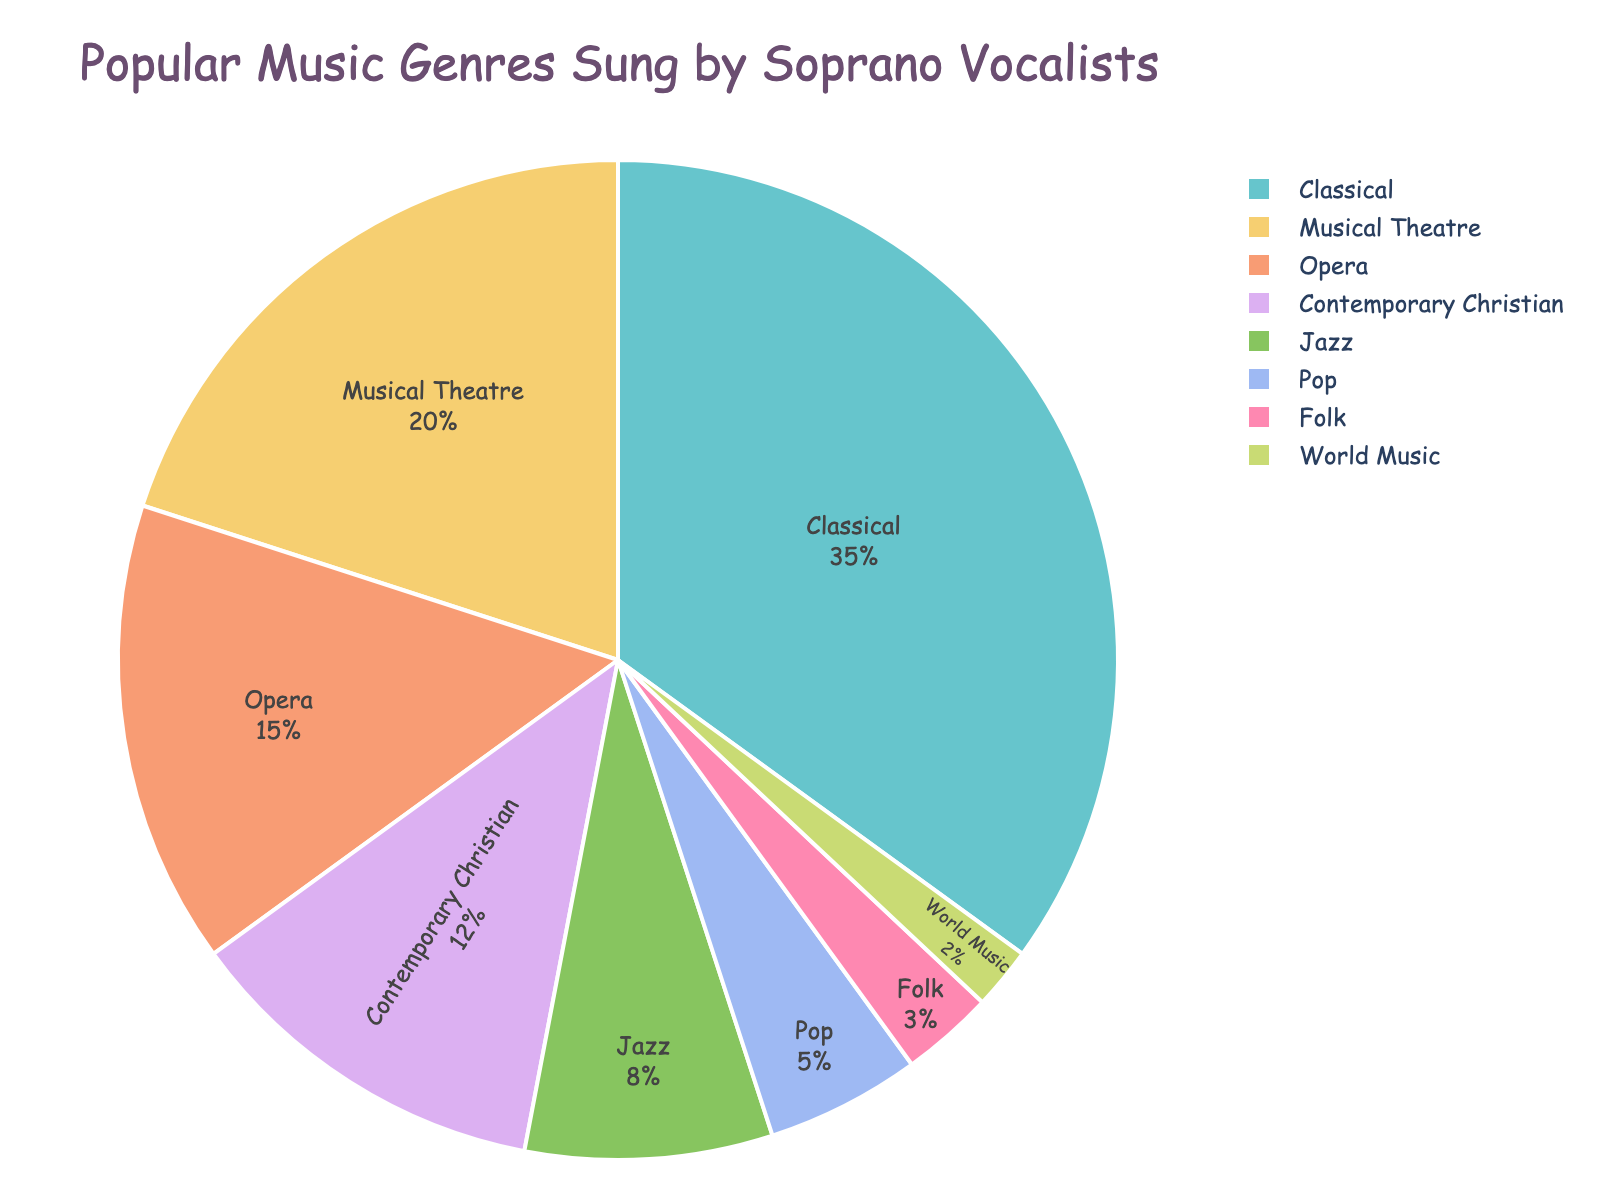What is the most popular music genre sung by soprano vocalists? The pie chart shows the breakdown of popular music genres sung by soprano vocalists by their percentages. The segment with the highest percentage represents the most popular genre. By looking at the chart, we see that Classical has the highest percentage at 35%.
Answer: Classical Which genre has a larger percentage, Opera or Contemporary Christian? To determine which genre has a larger percentage, we compare the slices in the pie chart labeled "Opera" and "Contemporary Christian". Opera has a percentage of 15%, while Contemporary Christian has 12%.
Answer: Opera What is the combined percentage of Musical Theatre and Jazz? We need to sum the percentages of Musical Theatre and Jazz as shown in the pie chart. Musical Theatre is 20% and Jazz is 8%, so the combined percentage is 20% + 8% = 28%.
Answer: 28% How much larger is the Classical genre compared to Pop? To find out how much larger the Classical genre is compared to the Pop genre, we subtract the percentage of Pop from the percentage of Classical. Classical has 35%, and Pop has 5%, so the difference is 35% - 5% = 30%.
Answer: 30% Which genre is represented by the smallest slice in the pie chart? The smallest slice in the pie chart represents the genre with the lowest percentage. By examining the chart, we see that World Music has the smallest slice at 2%.
Answer: World Music Are there any genres with similar percentage values? We look for genres with close or identical percentages in the pie chart. Musical Theatre and Opera are the closest, with 20% and 15%, respectively, but they are not equal. Similarly, Jazz and Pop have close percentages of 8% and 5%.
Answer: No exact matches, but Musical Theatre and Opera are close (20% and 15%) What is the total percentage of genres other than Classical, Musical Theatre, and Opera? We need to subtract the sum of the percentages for Classical, Musical Theatre, and Opera from 100%. So, 100% - (35% + 20% + 15%) = 100% - 70% = 30%.
Answer: 30% Which genre has a lower percentage, Jazz or Pop? By comparing the slices labeled "Jazz" and "Pop" in the pie chart, we see that Jazz has a percentage of 8%, while Pop has 5%. Pop has the lower percentage.
Answer: Pop What is the difference between the percentages of Contemporary Christian and Folk? We find the difference by subtracting the percentage of Folk from that of Contemporary Christian. Contemporary Christian has 12%, and Folk has 3%, so the difference is 12% - 3% = 9%.
Answer: 9% Is there any genre that holds exactly 10% of the total? We look at each slice's percentage in the pie chart. None of the genres have a percentage of exactly 10%. The closest is Contemporary Christian at 12%.
Answer: No 